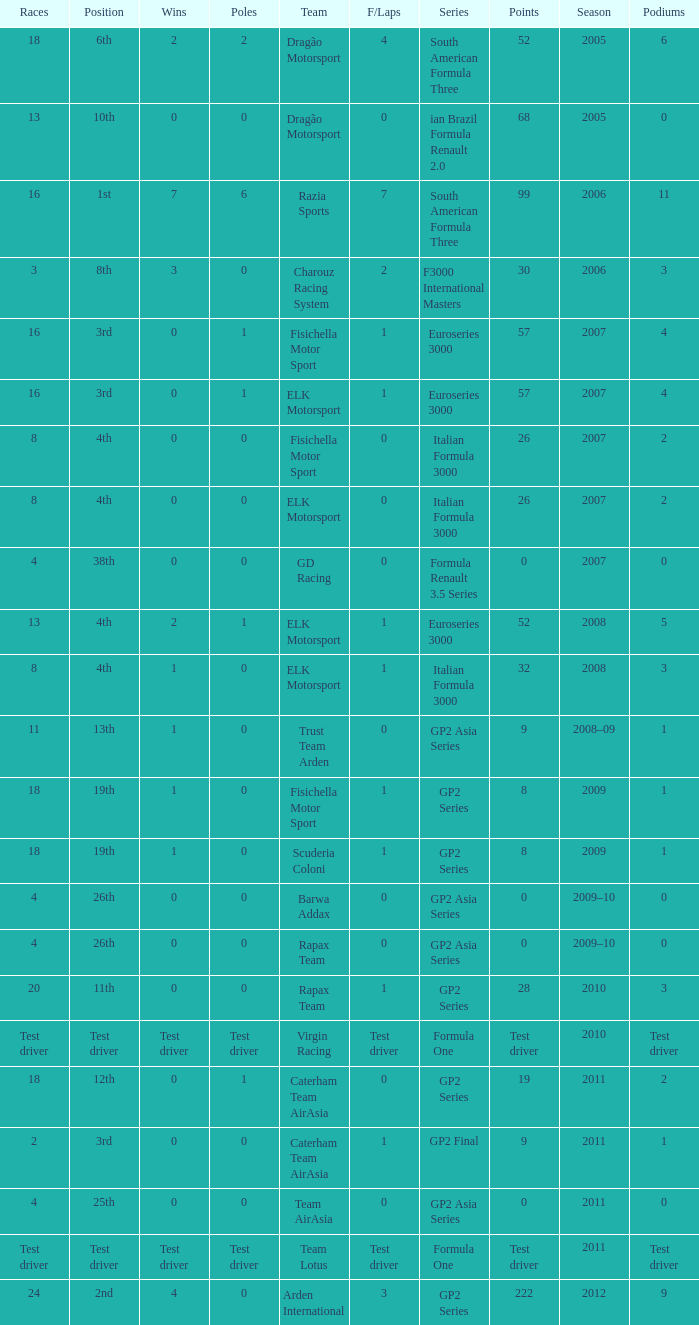What were the points in the year when his Wins were 0, his Podiums were 0, and he drove in 4 races? 0, 0, 0, 0. 